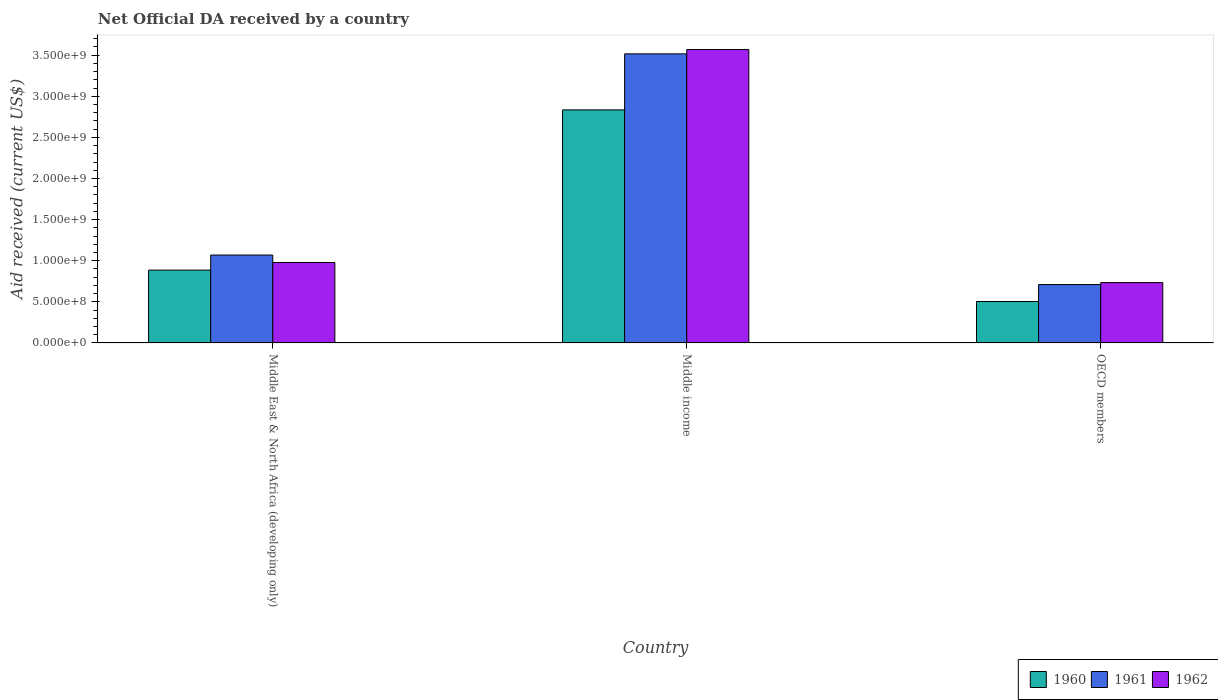How many different coloured bars are there?
Offer a terse response. 3. Are the number of bars on each tick of the X-axis equal?
Provide a short and direct response. Yes. What is the label of the 3rd group of bars from the left?
Ensure brevity in your answer.  OECD members. What is the net official development assistance aid received in 1962 in Middle East & North Africa (developing only)?
Offer a terse response. 9.78e+08. Across all countries, what is the maximum net official development assistance aid received in 1962?
Provide a short and direct response. 3.57e+09. Across all countries, what is the minimum net official development assistance aid received in 1962?
Make the answer very short. 7.34e+08. In which country was the net official development assistance aid received in 1960 minimum?
Provide a short and direct response. OECD members. What is the total net official development assistance aid received in 1960 in the graph?
Your answer should be compact. 4.22e+09. What is the difference between the net official development assistance aid received in 1962 in Middle income and that in OECD members?
Your answer should be very brief. 2.83e+09. What is the difference between the net official development assistance aid received in 1960 in OECD members and the net official development assistance aid received in 1962 in Middle income?
Give a very brief answer. -3.06e+09. What is the average net official development assistance aid received in 1961 per country?
Your answer should be very brief. 1.76e+09. What is the difference between the net official development assistance aid received of/in 1961 and net official development assistance aid received of/in 1962 in Middle income?
Offer a very short reply. -5.24e+07. In how many countries, is the net official development assistance aid received in 1962 greater than 1400000000 US$?
Ensure brevity in your answer.  1. What is the ratio of the net official development assistance aid received in 1960 in Middle income to that in OECD members?
Offer a terse response. 5.62. What is the difference between the highest and the second highest net official development assistance aid received in 1961?
Provide a short and direct response. 2.45e+09. What is the difference between the highest and the lowest net official development assistance aid received in 1962?
Make the answer very short. 2.83e+09. What does the 1st bar from the left in Middle income represents?
Make the answer very short. 1960. Is it the case that in every country, the sum of the net official development assistance aid received in 1962 and net official development assistance aid received in 1960 is greater than the net official development assistance aid received in 1961?
Ensure brevity in your answer.  Yes. How many bars are there?
Your response must be concise. 9. Are all the bars in the graph horizontal?
Your answer should be very brief. No. What is the difference between two consecutive major ticks on the Y-axis?
Make the answer very short. 5.00e+08. Are the values on the major ticks of Y-axis written in scientific E-notation?
Provide a succinct answer. Yes. Does the graph contain grids?
Your answer should be very brief. No. Where does the legend appear in the graph?
Make the answer very short. Bottom right. How many legend labels are there?
Provide a succinct answer. 3. How are the legend labels stacked?
Keep it short and to the point. Horizontal. What is the title of the graph?
Give a very brief answer. Net Official DA received by a country. Does "2002" appear as one of the legend labels in the graph?
Your response must be concise. No. What is the label or title of the X-axis?
Make the answer very short. Country. What is the label or title of the Y-axis?
Provide a short and direct response. Aid received (current US$). What is the Aid received (current US$) of 1960 in Middle East & North Africa (developing only)?
Offer a terse response. 8.86e+08. What is the Aid received (current US$) in 1961 in Middle East & North Africa (developing only)?
Your answer should be very brief. 1.07e+09. What is the Aid received (current US$) of 1962 in Middle East & North Africa (developing only)?
Your response must be concise. 9.78e+08. What is the Aid received (current US$) in 1960 in Middle income?
Offer a very short reply. 2.83e+09. What is the Aid received (current US$) in 1961 in Middle income?
Provide a succinct answer. 3.52e+09. What is the Aid received (current US$) of 1962 in Middle income?
Make the answer very short. 3.57e+09. What is the Aid received (current US$) of 1960 in OECD members?
Your response must be concise. 5.04e+08. What is the Aid received (current US$) of 1961 in OECD members?
Ensure brevity in your answer.  7.10e+08. What is the Aid received (current US$) of 1962 in OECD members?
Give a very brief answer. 7.34e+08. Across all countries, what is the maximum Aid received (current US$) in 1960?
Your response must be concise. 2.83e+09. Across all countries, what is the maximum Aid received (current US$) in 1961?
Provide a short and direct response. 3.52e+09. Across all countries, what is the maximum Aid received (current US$) of 1962?
Your answer should be compact. 3.57e+09. Across all countries, what is the minimum Aid received (current US$) in 1960?
Your response must be concise. 5.04e+08. Across all countries, what is the minimum Aid received (current US$) of 1961?
Keep it short and to the point. 7.10e+08. Across all countries, what is the minimum Aid received (current US$) in 1962?
Provide a short and direct response. 7.34e+08. What is the total Aid received (current US$) of 1960 in the graph?
Ensure brevity in your answer.  4.22e+09. What is the total Aid received (current US$) of 1961 in the graph?
Your answer should be very brief. 5.29e+09. What is the total Aid received (current US$) in 1962 in the graph?
Ensure brevity in your answer.  5.28e+09. What is the difference between the Aid received (current US$) of 1960 in Middle East & North Africa (developing only) and that in Middle income?
Ensure brevity in your answer.  -1.95e+09. What is the difference between the Aid received (current US$) of 1961 in Middle East & North Africa (developing only) and that in Middle income?
Provide a succinct answer. -2.45e+09. What is the difference between the Aid received (current US$) in 1962 in Middle East & North Africa (developing only) and that in Middle income?
Provide a succinct answer. -2.59e+09. What is the difference between the Aid received (current US$) in 1960 in Middle East & North Africa (developing only) and that in OECD members?
Keep it short and to the point. 3.81e+08. What is the difference between the Aid received (current US$) of 1961 in Middle East & North Africa (developing only) and that in OECD members?
Provide a short and direct response. 3.59e+08. What is the difference between the Aid received (current US$) in 1962 in Middle East & North Africa (developing only) and that in OECD members?
Offer a terse response. 2.44e+08. What is the difference between the Aid received (current US$) in 1960 in Middle income and that in OECD members?
Offer a very short reply. 2.33e+09. What is the difference between the Aid received (current US$) of 1961 in Middle income and that in OECD members?
Offer a terse response. 2.81e+09. What is the difference between the Aid received (current US$) of 1962 in Middle income and that in OECD members?
Provide a succinct answer. 2.83e+09. What is the difference between the Aid received (current US$) of 1960 in Middle East & North Africa (developing only) and the Aid received (current US$) of 1961 in Middle income?
Make the answer very short. -2.63e+09. What is the difference between the Aid received (current US$) of 1960 in Middle East & North Africa (developing only) and the Aid received (current US$) of 1962 in Middle income?
Offer a terse response. -2.68e+09. What is the difference between the Aid received (current US$) of 1961 in Middle East & North Africa (developing only) and the Aid received (current US$) of 1962 in Middle income?
Your answer should be compact. -2.50e+09. What is the difference between the Aid received (current US$) in 1960 in Middle East & North Africa (developing only) and the Aid received (current US$) in 1961 in OECD members?
Give a very brief answer. 1.76e+08. What is the difference between the Aid received (current US$) in 1960 in Middle East & North Africa (developing only) and the Aid received (current US$) in 1962 in OECD members?
Offer a very short reply. 1.52e+08. What is the difference between the Aid received (current US$) of 1961 in Middle East & North Africa (developing only) and the Aid received (current US$) of 1962 in OECD members?
Offer a terse response. 3.35e+08. What is the difference between the Aid received (current US$) of 1960 in Middle income and the Aid received (current US$) of 1961 in OECD members?
Your response must be concise. 2.12e+09. What is the difference between the Aid received (current US$) in 1960 in Middle income and the Aid received (current US$) in 1962 in OECD members?
Make the answer very short. 2.10e+09. What is the difference between the Aid received (current US$) in 1961 in Middle income and the Aid received (current US$) in 1962 in OECD members?
Provide a short and direct response. 2.78e+09. What is the average Aid received (current US$) of 1960 per country?
Keep it short and to the point. 1.41e+09. What is the average Aid received (current US$) of 1961 per country?
Offer a terse response. 1.76e+09. What is the average Aid received (current US$) of 1962 per country?
Your response must be concise. 1.76e+09. What is the difference between the Aid received (current US$) of 1960 and Aid received (current US$) of 1961 in Middle East & North Africa (developing only)?
Provide a short and direct response. -1.83e+08. What is the difference between the Aid received (current US$) in 1960 and Aid received (current US$) in 1962 in Middle East & North Africa (developing only)?
Ensure brevity in your answer.  -9.25e+07. What is the difference between the Aid received (current US$) in 1961 and Aid received (current US$) in 1962 in Middle East & North Africa (developing only)?
Offer a very short reply. 9.09e+07. What is the difference between the Aid received (current US$) of 1960 and Aid received (current US$) of 1961 in Middle income?
Make the answer very short. -6.81e+08. What is the difference between the Aid received (current US$) of 1960 and Aid received (current US$) of 1962 in Middle income?
Offer a very short reply. -7.34e+08. What is the difference between the Aid received (current US$) of 1961 and Aid received (current US$) of 1962 in Middle income?
Your answer should be very brief. -5.24e+07. What is the difference between the Aid received (current US$) of 1960 and Aid received (current US$) of 1961 in OECD members?
Ensure brevity in your answer.  -2.06e+08. What is the difference between the Aid received (current US$) of 1960 and Aid received (current US$) of 1962 in OECD members?
Give a very brief answer. -2.30e+08. What is the difference between the Aid received (current US$) of 1961 and Aid received (current US$) of 1962 in OECD members?
Offer a terse response. -2.41e+07. What is the ratio of the Aid received (current US$) of 1960 in Middle East & North Africa (developing only) to that in Middle income?
Provide a short and direct response. 0.31. What is the ratio of the Aid received (current US$) of 1961 in Middle East & North Africa (developing only) to that in Middle income?
Give a very brief answer. 0.3. What is the ratio of the Aid received (current US$) of 1962 in Middle East & North Africa (developing only) to that in Middle income?
Your answer should be compact. 0.27. What is the ratio of the Aid received (current US$) in 1960 in Middle East & North Africa (developing only) to that in OECD members?
Give a very brief answer. 1.76. What is the ratio of the Aid received (current US$) in 1961 in Middle East & North Africa (developing only) to that in OECD members?
Offer a terse response. 1.51. What is the ratio of the Aid received (current US$) of 1962 in Middle East & North Africa (developing only) to that in OECD members?
Your response must be concise. 1.33. What is the ratio of the Aid received (current US$) in 1960 in Middle income to that in OECD members?
Keep it short and to the point. 5.62. What is the ratio of the Aid received (current US$) in 1961 in Middle income to that in OECD members?
Your answer should be compact. 4.95. What is the ratio of the Aid received (current US$) in 1962 in Middle income to that in OECD members?
Ensure brevity in your answer.  4.86. What is the difference between the highest and the second highest Aid received (current US$) of 1960?
Your answer should be very brief. 1.95e+09. What is the difference between the highest and the second highest Aid received (current US$) of 1961?
Your answer should be very brief. 2.45e+09. What is the difference between the highest and the second highest Aid received (current US$) of 1962?
Provide a succinct answer. 2.59e+09. What is the difference between the highest and the lowest Aid received (current US$) in 1960?
Offer a terse response. 2.33e+09. What is the difference between the highest and the lowest Aid received (current US$) of 1961?
Your answer should be compact. 2.81e+09. What is the difference between the highest and the lowest Aid received (current US$) in 1962?
Your answer should be very brief. 2.83e+09. 